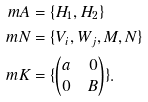<formula> <loc_0><loc_0><loc_500><loc_500>\ m A & = \{ H _ { 1 } , H _ { 2 } \} \\ \ m N & = \{ V _ { i } , W _ { j } , M , N \} \\ \ m K & = \{ \begin{pmatrix} a & 0 \\ 0 & B \end{pmatrix} \} .</formula> 